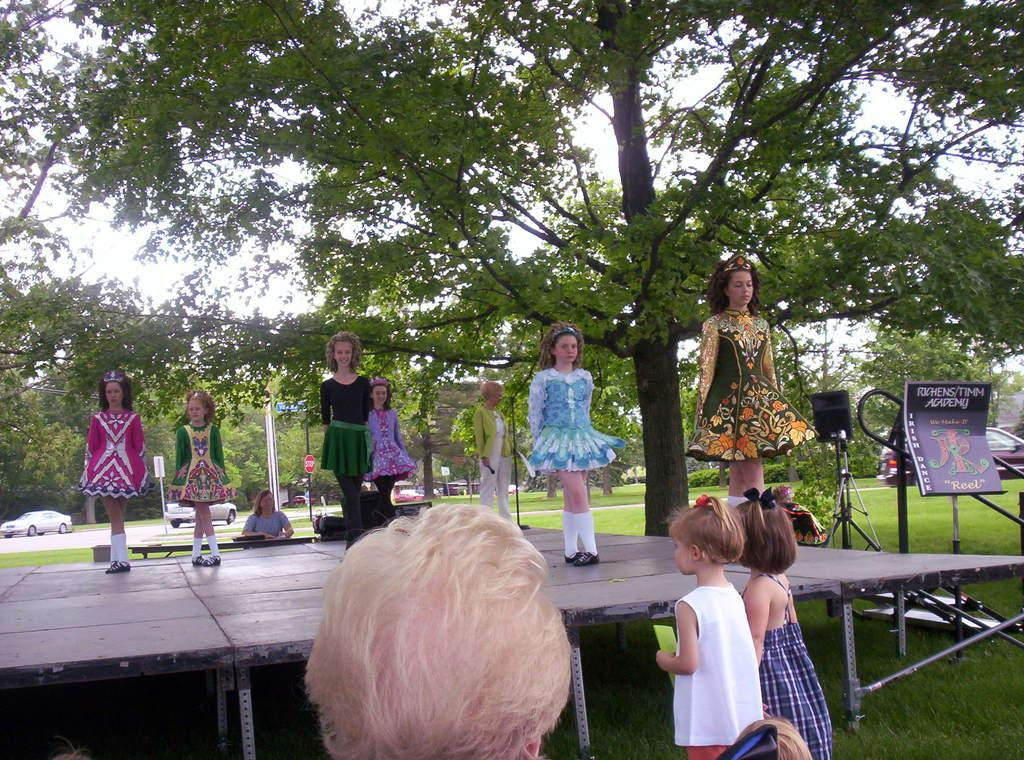Who or what is present in the image? There are people in the image. What can be seen on the right side of the image? There is a board with text on the right side of the image. What is visible in the background of the image? Vehicles and trees are present in the background of the image. Can you see a crow flying over the people in the image? There is no crow visible in the image. What type of cork is being used by the people in the image? There is no cork present in the image. 